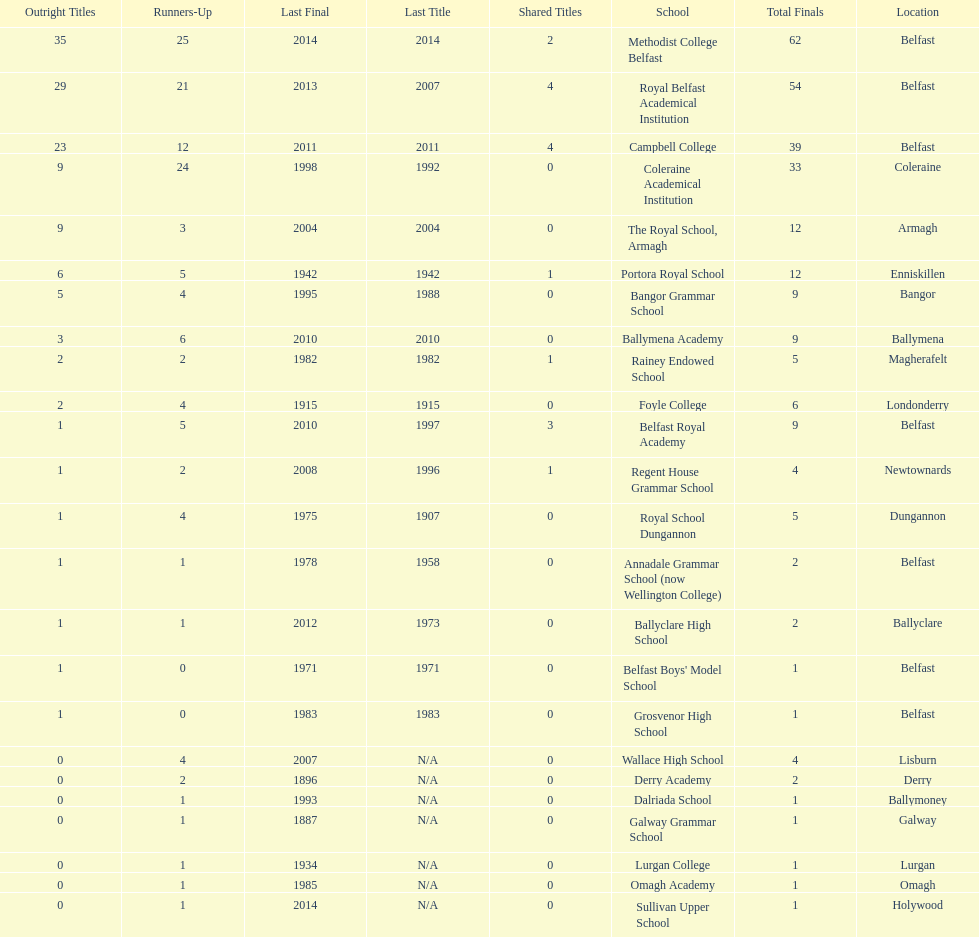How many schools had above 5 outright titles? 6. 